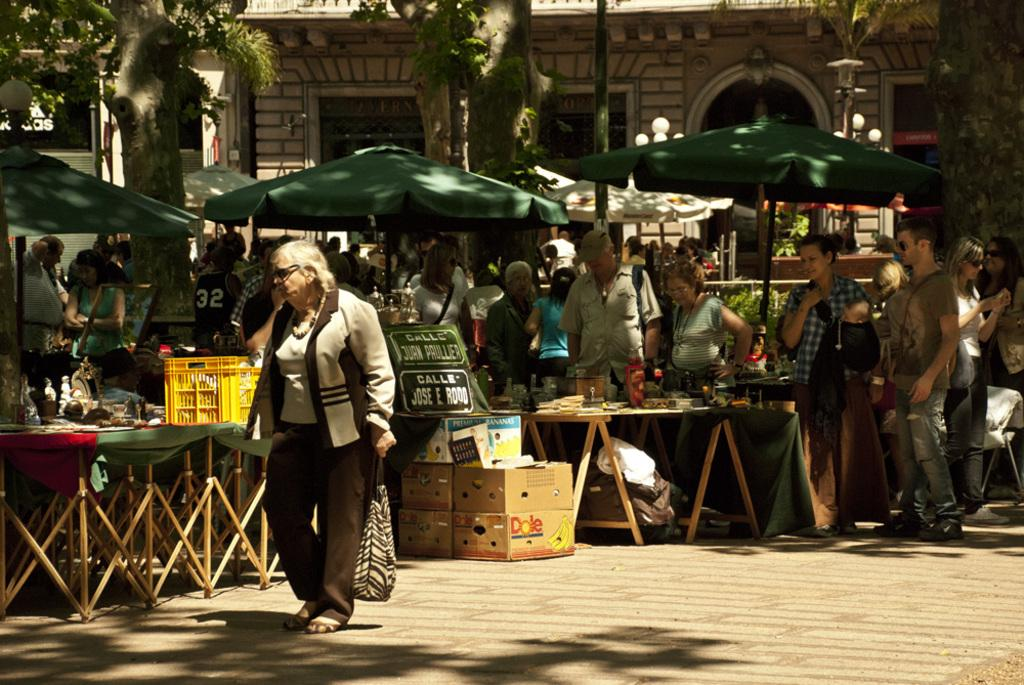Provide a one-sentence caption for the provided image. Boxes with Dole fruit depicted on the side sit near stands on the street. 